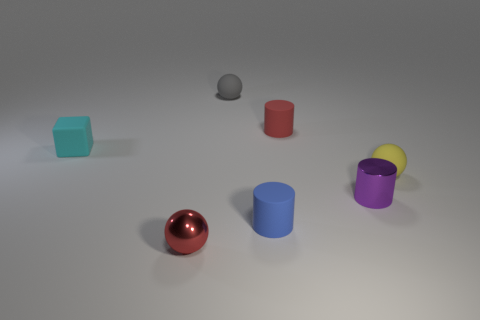There is a shiny object right of the small sphere that is in front of the purple shiny object; what is its color?
Your response must be concise. Purple. Is the number of rubber cylinders less than the number of tiny balls?
Your answer should be very brief. Yes. Is there a large blue ball made of the same material as the small gray object?
Keep it short and to the point. No. There is a tiny yellow thing; is it the same shape as the thing that is behind the tiny red matte cylinder?
Give a very brief answer. Yes. There is a small red rubber cylinder; are there any tiny red things in front of it?
Your answer should be very brief. Yes. What number of gray objects are the same shape as the red metallic object?
Give a very brief answer. 1. Do the tiny red cylinder and the tiny object that is left of the tiny red shiny thing have the same material?
Offer a terse response. Yes. What number of tiny objects are there?
Provide a succinct answer. 7. What number of purple metal cylinders have the same size as the cyan rubber thing?
Make the answer very short. 1. There is a small object that is both on the left side of the gray object and in front of the block; what material is it made of?
Make the answer very short. Metal. 